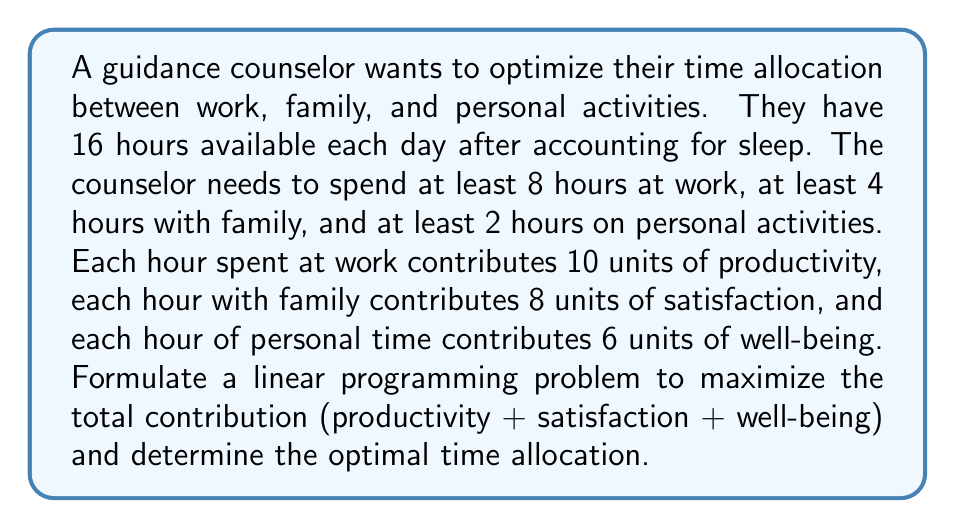Show me your answer to this math problem. Let's approach this problem step-by-step using linear programming:

1) Define variables:
   Let $x$ = hours spent at work
   Let $y$ = hours spent with family
   Let $z$ = hours spent on personal activities

2) Objective function:
   We want to maximize the total contribution:
   $\text{Maximize } 10x + 8y + 6z$

3) Constraints:
   a) Total time available: $x + y + z = 16$
   b) Minimum work time: $x \geq 8$
   c) Minimum family time: $y \geq 4$
   d) Minimum personal time: $z \geq 2$
   e) Non-negativity: $x, y, z \geq 0$

4) The linear programming problem:

   $$\begin{aligned}
   \text{Maximize: } & 10x + 8y + 6z \\
   \text{Subject to: } & x + y + z = 16 \\
   & x \geq 8 \\
   & y \geq 4 \\
   & z \geq 2 \\
   & x, y, z \geq 0
   \end{aligned}$$

5) Solving the problem:
   We can solve this using the simplex method or graphically. Given the constraints, the feasible region is a triangle on the plane $x + y + z = 16$.

6) The optimal solution will be at one of the vertices of this feasible region. The vertices are:
   (8, 4, 4), (8, 6, 2), and (10, 4, 2)

7) Evaluating the objective function at these points:
   (8, 4, 4): $10(8) + 8(4) + 6(4) = 132$
   (8, 6, 2): $10(8) + 8(6) + 6(2) = 140$
   (10, 4, 2): $10(10) + 8(4) + 6(2) = 144$

Therefore, the optimal solution is (10, 4, 2), meaning 10 hours at work, 4 hours with family, and 2 hours for personal activities.
Answer: The optimal time allocation is 10 hours for work, 4 hours for family, and 2 hours for personal activities, resulting in a maximum total contribution of 144 units. 